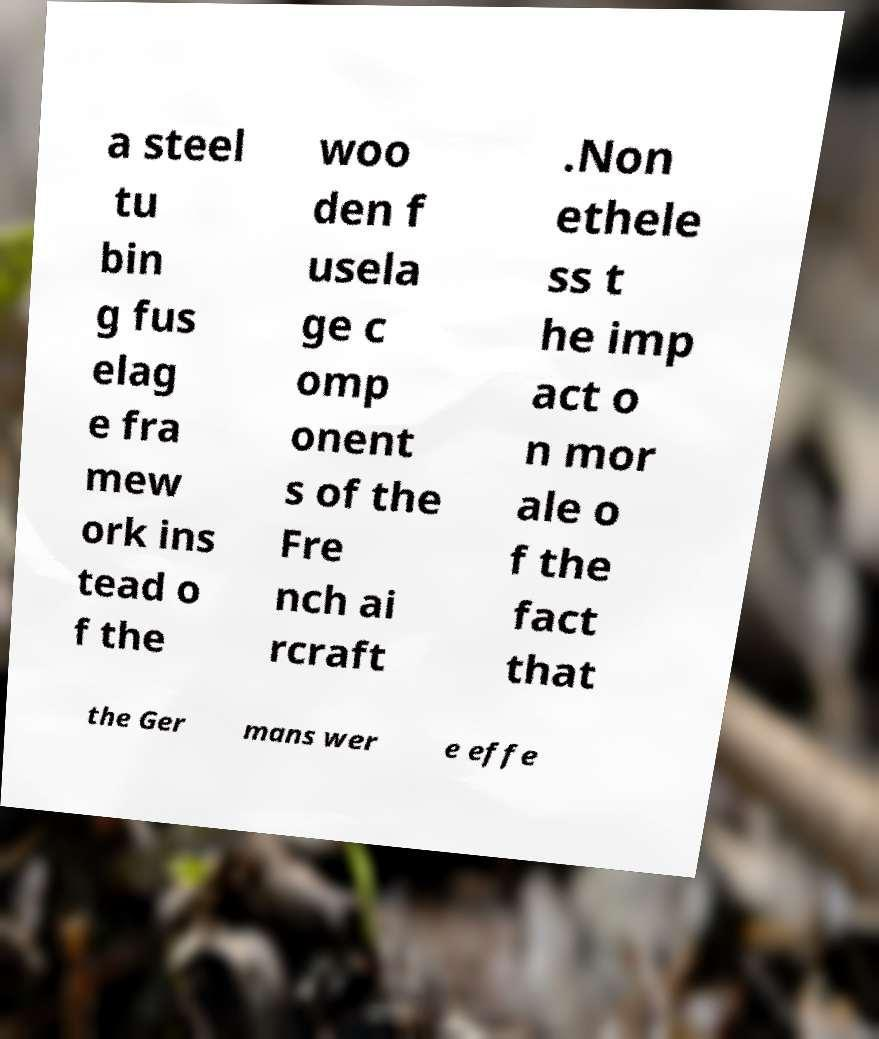Can you read and provide the text displayed in the image?This photo seems to have some interesting text. Can you extract and type it out for me? a steel tu bin g fus elag e fra mew ork ins tead o f the woo den f usela ge c omp onent s of the Fre nch ai rcraft .Non ethele ss t he imp act o n mor ale o f the fact that the Ger mans wer e effe 